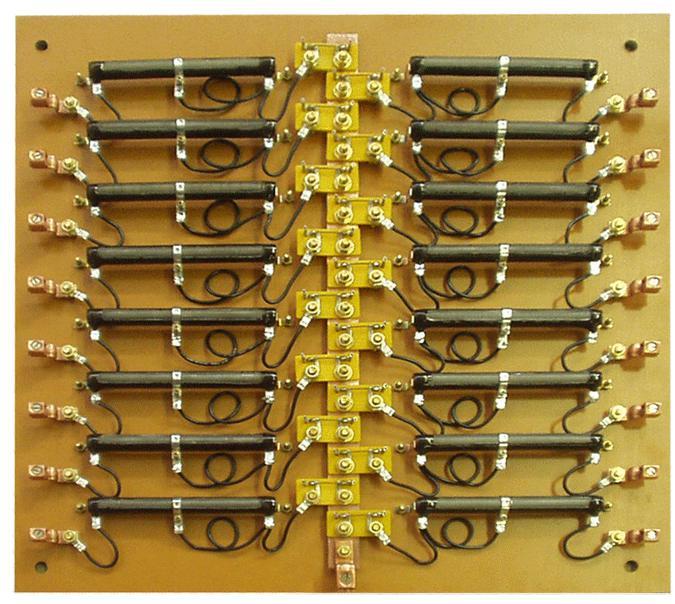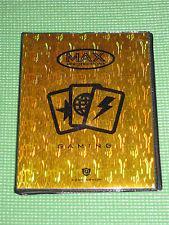The first image is the image on the left, the second image is the image on the right. For the images shown, is this caption "The image on the right is of a gold binder." true? Answer yes or no. Yes. 